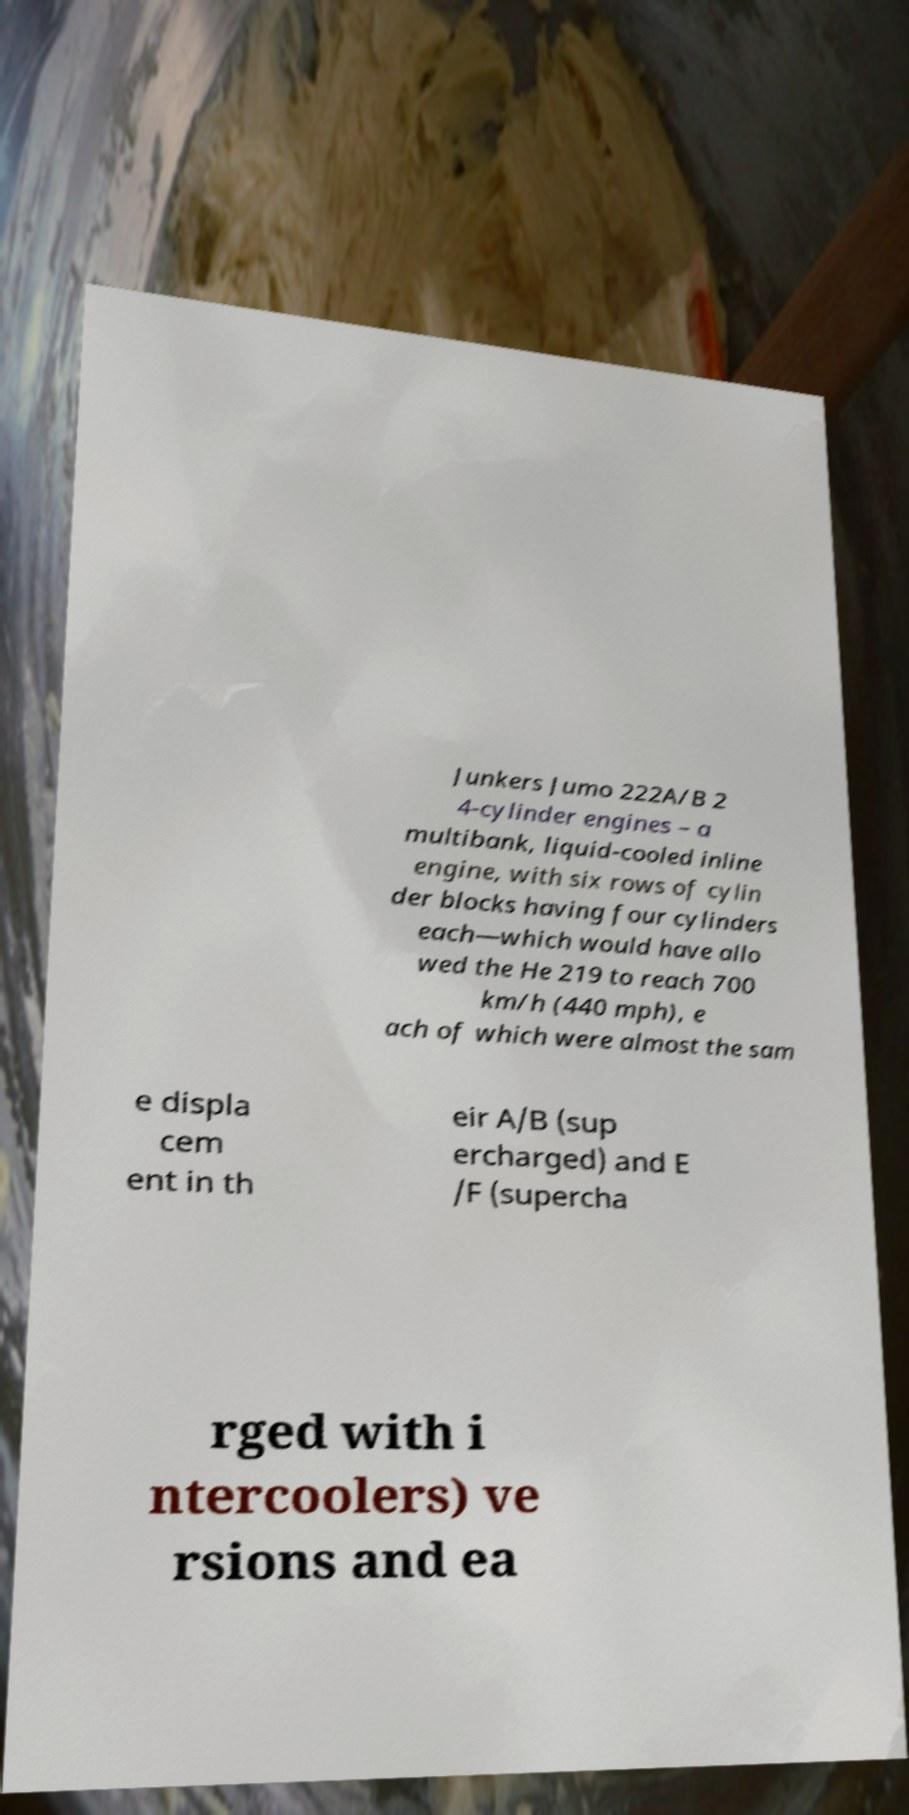Please identify and transcribe the text found in this image. Junkers Jumo 222A/B 2 4-cylinder engines – a multibank, liquid-cooled inline engine, with six rows of cylin der blocks having four cylinders each—which would have allo wed the He 219 to reach 700 km/h (440 mph), e ach of which were almost the sam e displa cem ent in th eir A/B (sup ercharged) and E /F (supercha rged with i ntercoolers) ve rsions and ea 